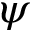Convert formula to latex. <formula><loc_0><loc_0><loc_500><loc_500>\psi</formula> 